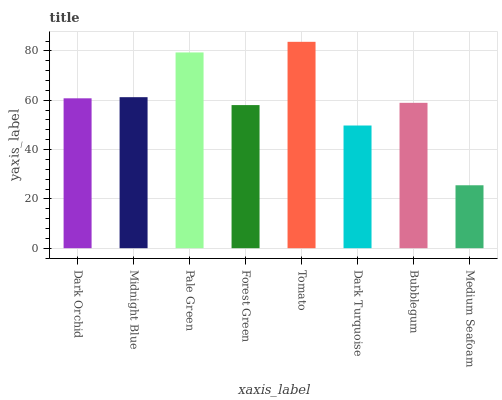Is Medium Seafoam the minimum?
Answer yes or no. Yes. Is Tomato the maximum?
Answer yes or no. Yes. Is Midnight Blue the minimum?
Answer yes or no. No. Is Midnight Blue the maximum?
Answer yes or no. No. Is Midnight Blue greater than Dark Orchid?
Answer yes or no. Yes. Is Dark Orchid less than Midnight Blue?
Answer yes or no. Yes. Is Dark Orchid greater than Midnight Blue?
Answer yes or no. No. Is Midnight Blue less than Dark Orchid?
Answer yes or no. No. Is Dark Orchid the high median?
Answer yes or no. Yes. Is Bubblegum the low median?
Answer yes or no. Yes. Is Bubblegum the high median?
Answer yes or no. No. Is Pale Green the low median?
Answer yes or no. No. 